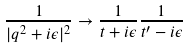<formula> <loc_0><loc_0><loc_500><loc_500>\frac { 1 } { | q ^ { 2 } + i \epsilon | ^ { 2 } } \to \frac { 1 } { t + i \epsilon } \frac { 1 } { t ^ { \prime } - i \epsilon }</formula> 